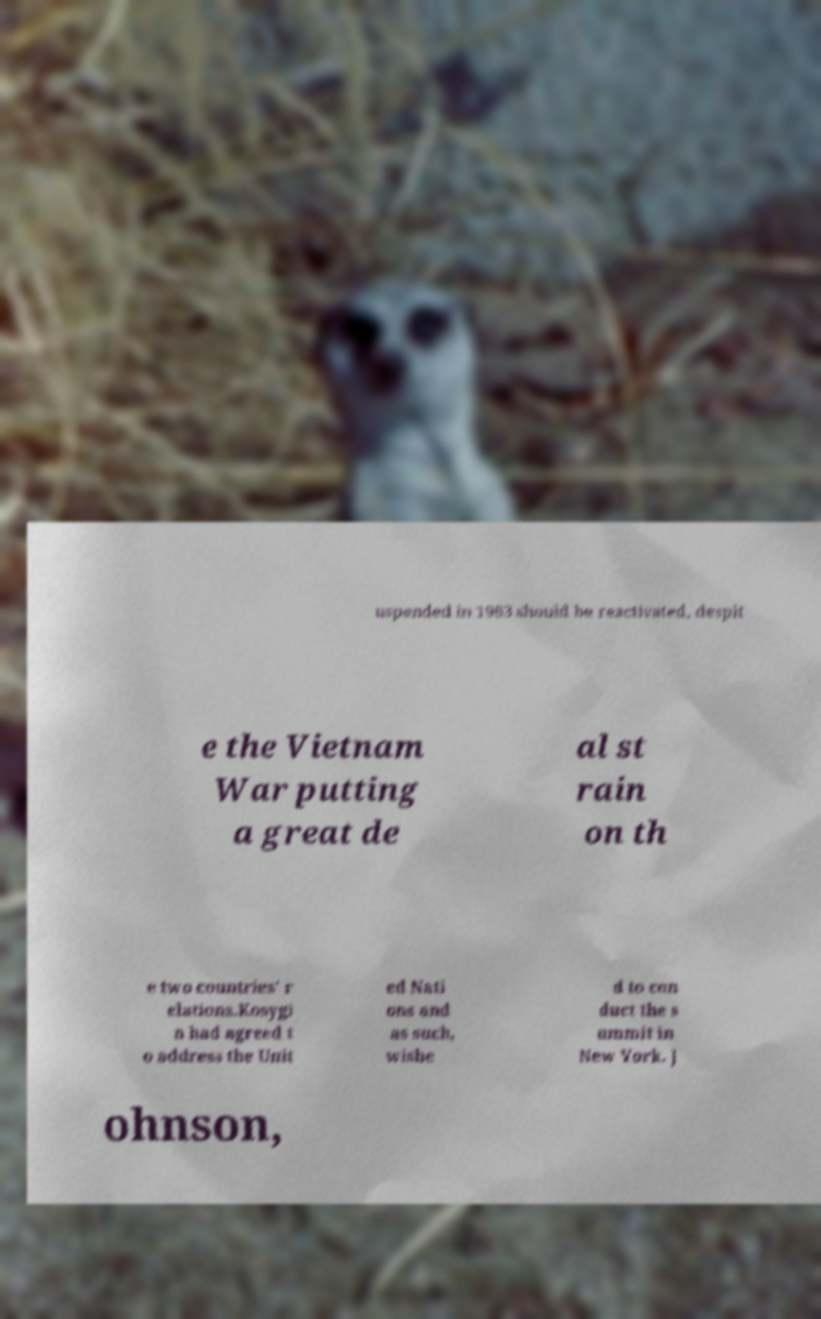Could you assist in decoding the text presented in this image and type it out clearly? uspended in 1963 should be reactivated, despit e the Vietnam War putting a great de al st rain on th e two countries' r elations.Kosygi n had agreed t o address the Unit ed Nati ons and as such, wishe d to con duct the s ummit in New York. J ohnson, 